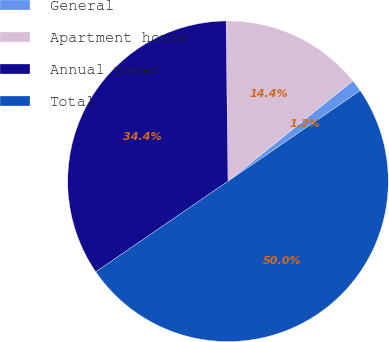Convert chart to OTSL. <chart><loc_0><loc_0><loc_500><loc_500><pie_chart><fcel>General<fcel>Apartment house<fcel>Annual power<fcel>Total<nl><fcel>1.22%<fcel>14.41%<fcel>34.37%<fcel>50.0%<nl></chart> 